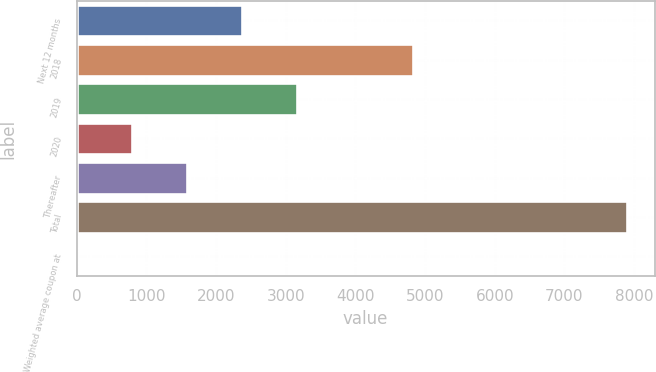Convert chart to OTSL. <chart><loc_0><loc_0><loc_500><loc_500><bar_chart><fcel>Next 12 months<fcel>2018<fcel>2019<fcel>2020<fcel>Thereafter<fcel>Total<fcel>Weighted average coupon at<nl><fcel>2370.75<fcel>4827<fcel>3160.5<fcel>791.25<fcel>1581<fcel>7899<fcel>1.5<nl></chart> 